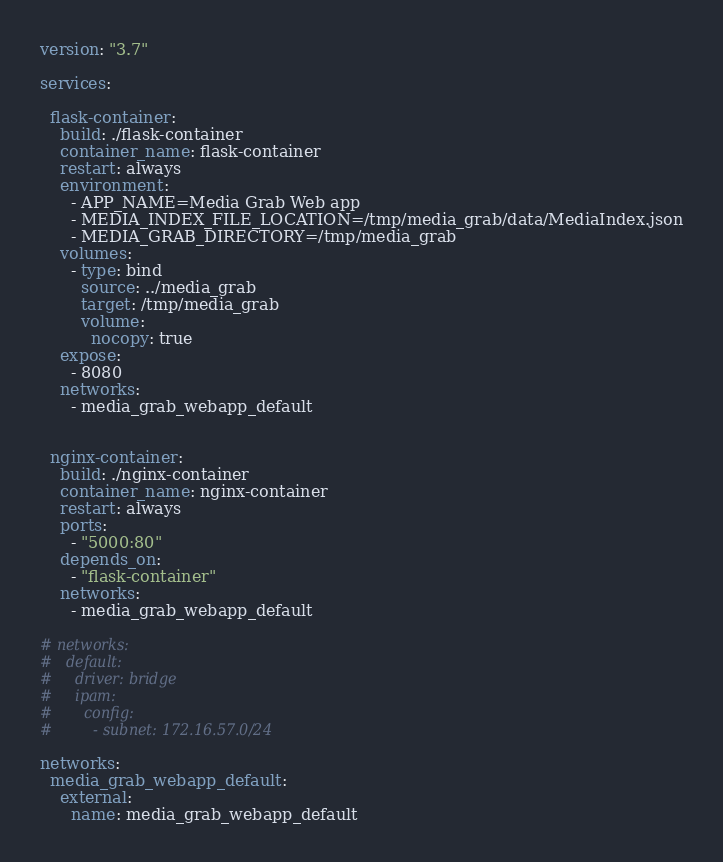<code> <loc_0><loc_0><loc_500><loc_500><_YAML_>version: "3.7"

services:

  flask-container:
    build: ./flask-container
    container_name: flask-container
    restart: always
    environment:
      - APP_NAME=Media Grab Web app
      - MEDIA_INDEX_FILE_LOCATION=/tmp/media_grab/data/MediaIndex.json
      - MEDIA_GRAB_DIRECTORY=/tmp/media_grab
    volumes:
      - type: bind
        source: ../media_grab
        target: /tmp/media_grab
        volume:
          nocopy: true
    expose:
      - 8080
    networks:
      - media_grab_webapp_default


  nginx-container:
    build: ./nginx-container
    container_name: nginx-container
    restart: always
    ports:
      - "5000:80"
    depends_on:
      - "flask-container"
    networks:
      - media_grab_webapp_default

# networks:
#   default:
#     driver: bridge
#     ipam:
#       config:
#         - subnet: 172.16.57.0/24

networks:
  media_grab_webapp_default:
    external:
      name: media_grab_webapp_default</code> 